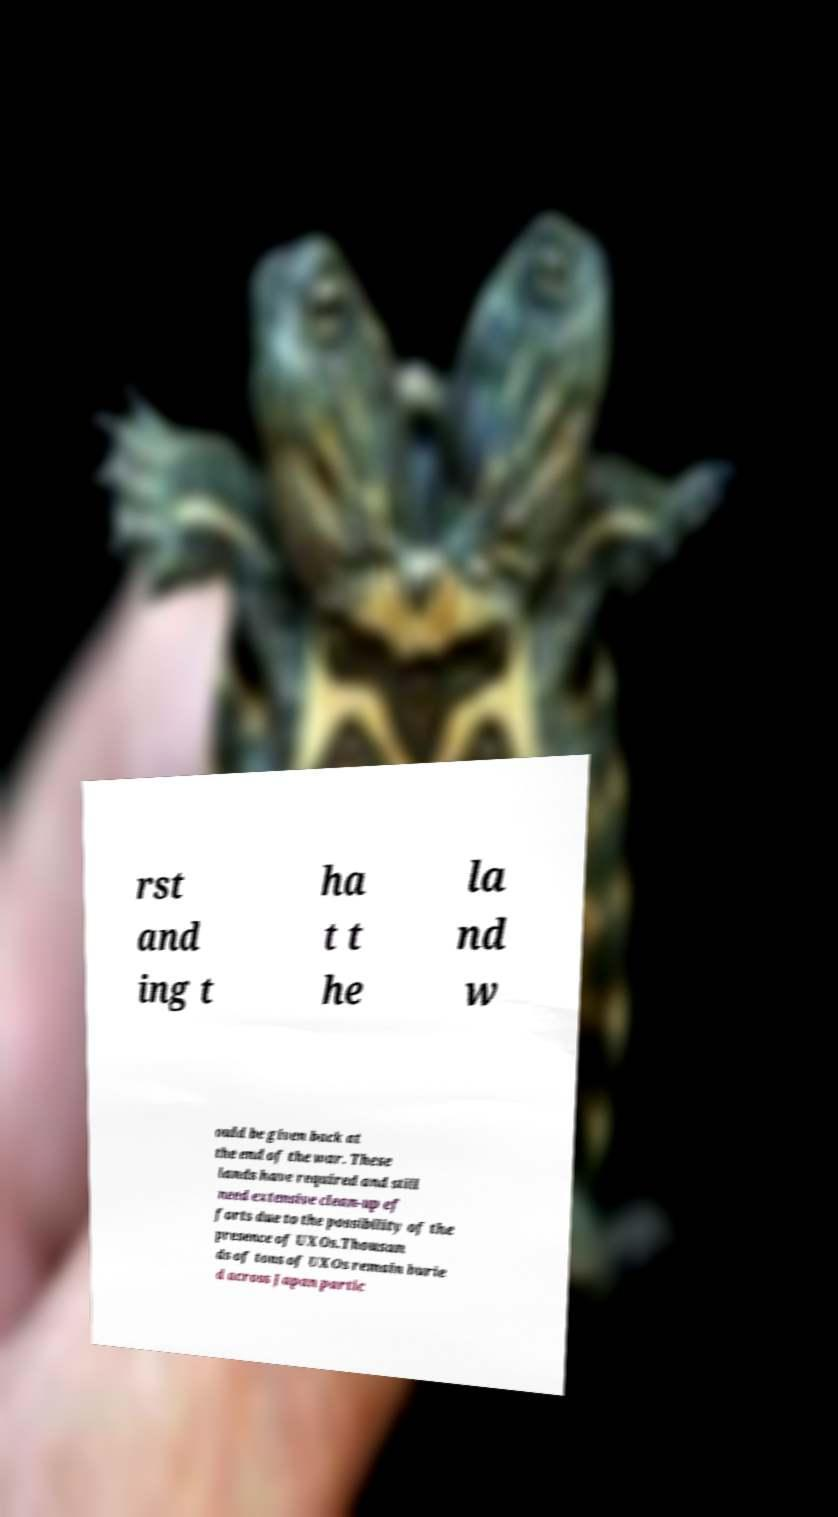Could you extract and type out the text from this image? rst and ing t ha t t he la nd w ould be given back at the end of the war. These lands have required and still need extensive clean-up ef forts due to the possibility of the presence of UXOs.Thousan ds of tons of UXOs remain burie d across Japan partic 